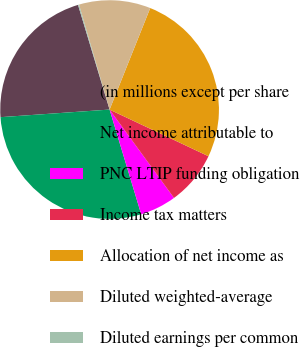Convert chart to OTSL. <chart><loc_0><loc_0><loc_500><loc_500><pie_chart><fcel>(in millions except per share<fcel>Net income attributable to<fcel>PNC LTIP funding obligation<fcel>Income tax matters<fcel>Allocation of net income as<fcel>Diluted weighted-average<fcel>Diluted earnings per common<nl><fcel>21.45%<fcel>28.56%<fcel>5.36%<fcel>7.96%<fcel>25.96%<fcel>10.57%<fcel>0.15%<nl></chart> 